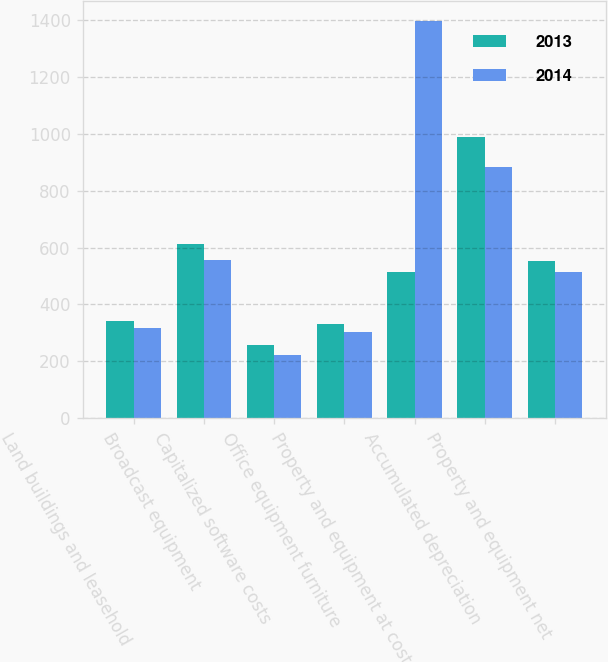<chart> <loc_0><loc_0><loc_500><loc_500><stacked_bar_chart><ecel><fcel>Land buildings and leasehold<fcel>Broadcast equipment<fcel>Capitalized software costs<fcel>Office equipment furniture<fcel>Property and equipment at cost<fcel>Accumulated depreciation<fcel>Property and equipment net<nl><fcel>2013<fcel>340<fcel>612<fcel>258<fcel>332<fcel>514<fcel>988<fcel>554<nl><fcel>2014<fcel>318<fcel>556<fcel>222<fcel>301<fcel>1397<fcel>883<fcel>514<nl></chart> 